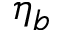Convert formula to latex. <formula><loc_0><loc_0><loc_500><loc_500>\eta _ { b }</formula> 